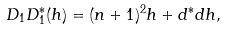Convert formula to latex. <formula><loc_0><loc_0><loc_500><loc_500>D _ { 1 } D _ { 1 } ^ { * } ( h ) = ( n + 1 ) ^ { 2 } h + d ^ { * } d h ,</formula> 